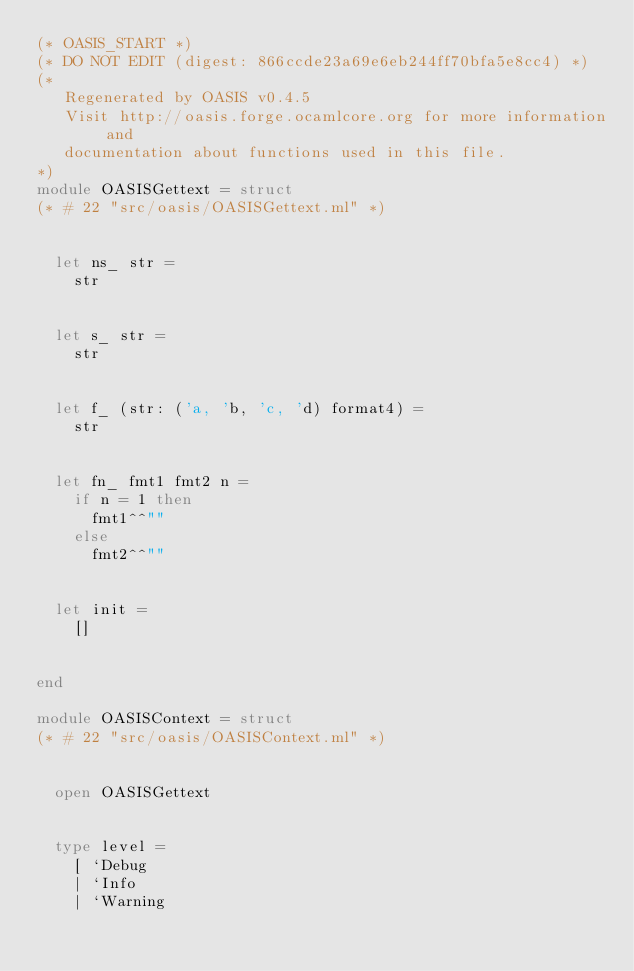<code> <loc_0><loc_0><loc_500><loc_500><_OCaml_>(* OASIS_START *)
(* DO NOT EDIT (digest: 866ccde23a69e6eb244ff70bfa5e8cc4) *)
(*
   Regenerated by OASIS v0.4.5
   Visit http://oasis.forge.ocamlcore.org for more information and
   documentation about functions used in this file.
*)
module OASISGettext = struct
(* # 22 "src/oasis/OASISGettext.ml" *)


  let ns_ str =
    str


  let s_ str =
    str


  let f_ (str: ('a, 'b, 'c, 'd) format4) =
    str


  let fn_ fmt1 fmt2 n =
    if n = 1 then
      fmt1^^""
    else
      fmt2^^""


  let init =
    []


end

module OASISContext = struct
(* # 22 "src/oasis/OASISContext.ml" *)


  open OASISGettext


  type level =
    [ `Debug
    | `Info
    | `Warning</code> 